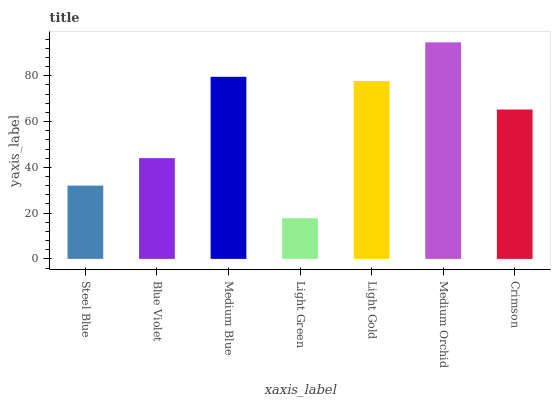Is Light Green the minimum?
Answer yes or no. Yes. Is Medium Orchid the maximum?
Answer yes or no. Yes. Is Blue Violet the minimum?
Answer yes or no. No. Is Blue Violet the maximum?
Answer yes or no. No. Is Blue Violet greater than Steel Blue?
Answer yes or no. Yes. Is Steel Blue less than Blue Violet?
Answer yes or no. Yes. Is Steel Blue greater than Blue Violet?
Answer yes or no. No. Is Blue Violet less than Steel Blue?
Answer yes or no. No. Is Crimson the high median?
Answer yes or no. Yes. Is Crimson the low median?
Answer yes or no. Yes. Is Medium Orchid the high median?
Answer yes or no. No. Is Steel Blue the low median?
Answer yes or no. No. 